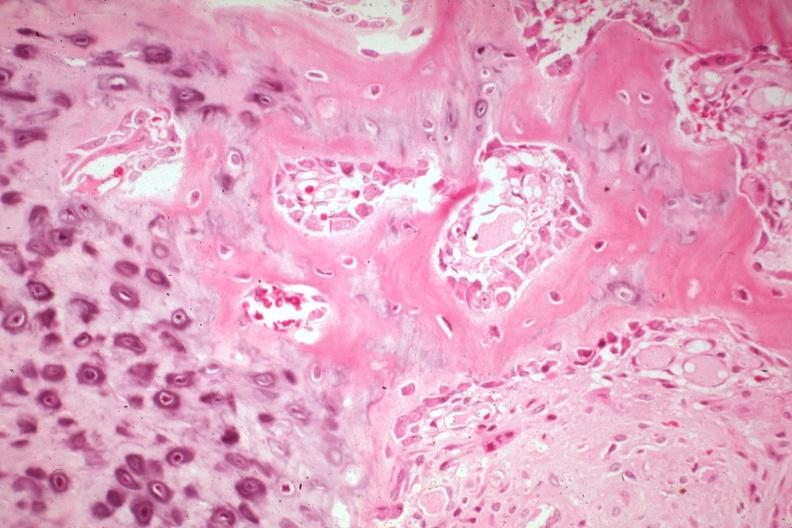what does this image show?
Answer the question using a single word or phrase. High excellent plus enchondral bone formation with osteoid osteoblasts from a non union 81 